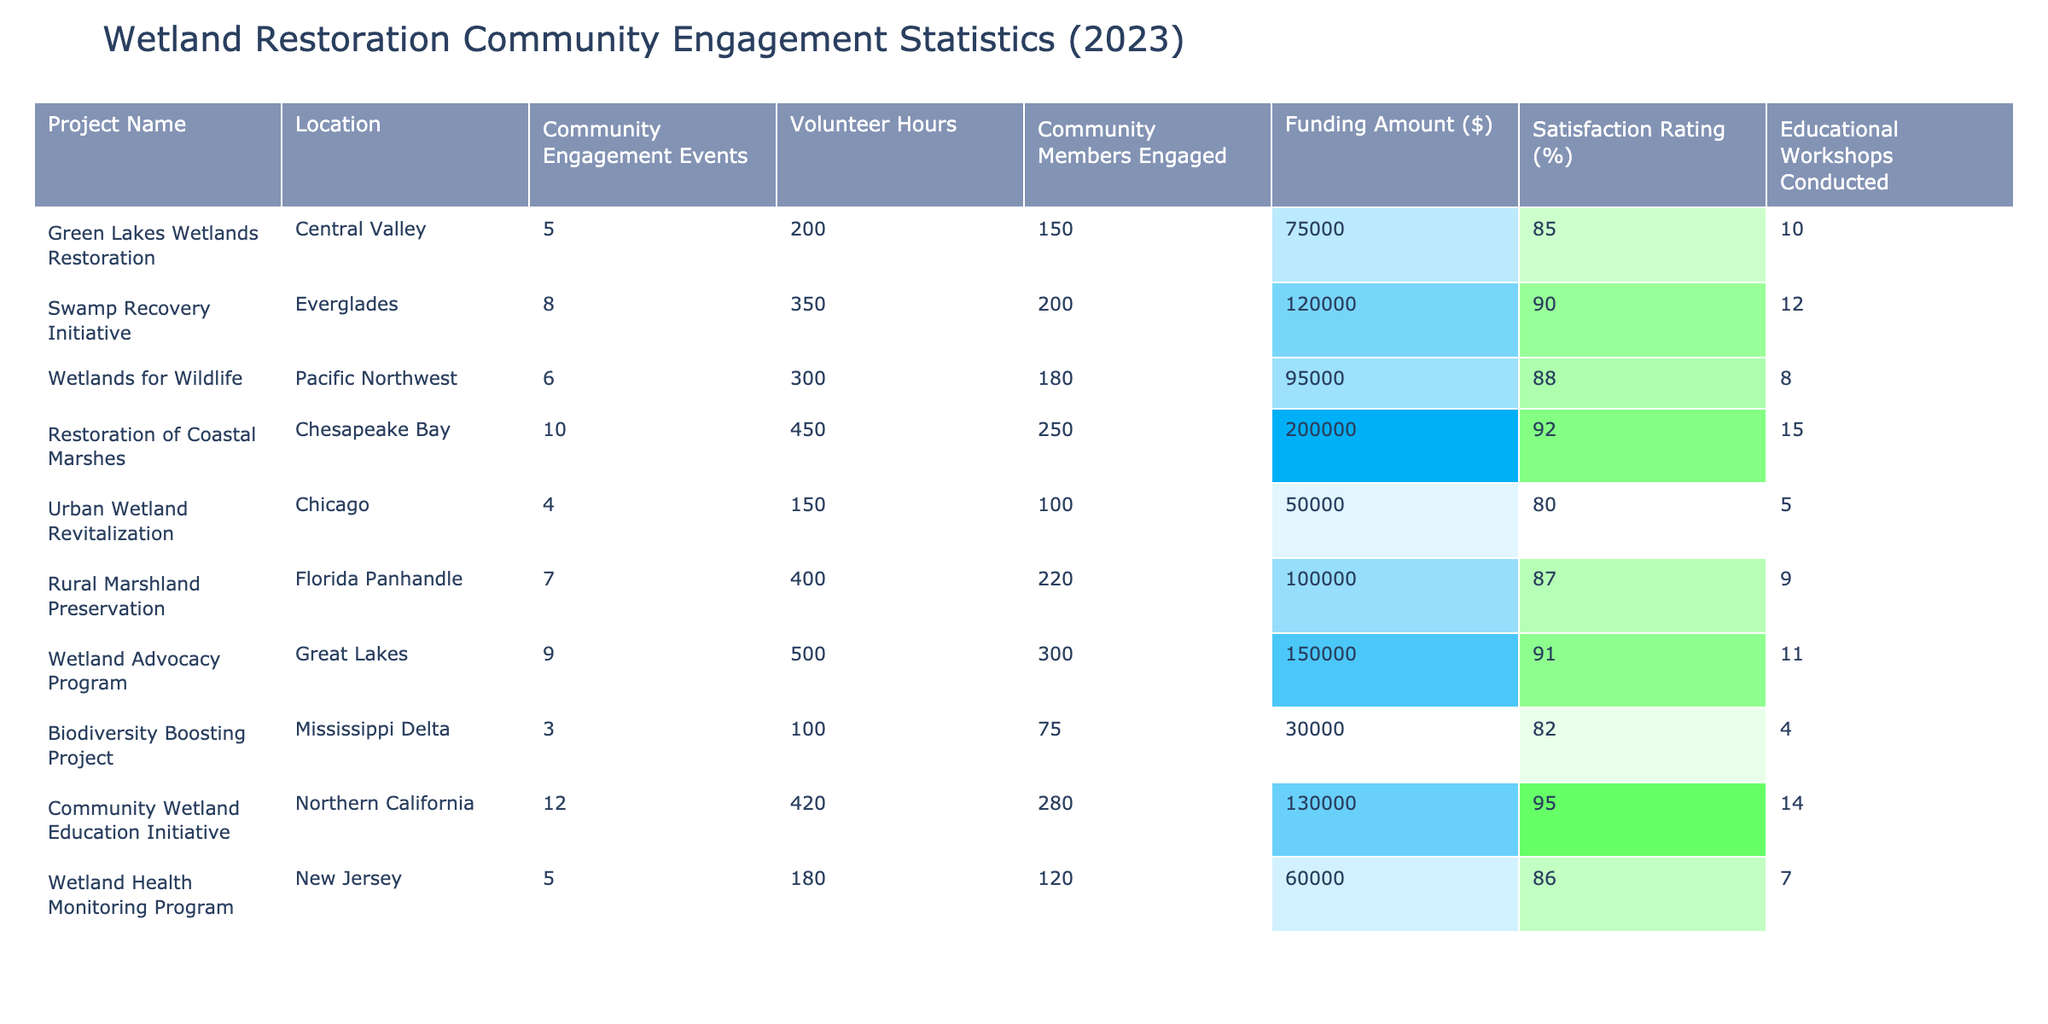What is the funding amount for the "Swamp Recovery Initiative"? The funding amount for the "Swamp Recovery Initiative" is listed in the table under the "Funding Amount ($)" column. The value given for this project is $120,000.
Answer: $120,000 How many community members were engaged in the "Urban Wetland Revitalization" project? The number of community members engaged in the "Urban Wetland Revitalization" project can be found in the "Community Members Engaged" column, which shows a value of 100.
Answer: 100 What is the satisfaction rating of the "Wetlands for Wildlife" project? The satisfaction rating is listed in the "Satisfaction Rating (%)" column. For the "Wetlands for Wildlife" project, the value is 88%.
Answer: 88% Which project had the highest number of community engagement events? To find the project with the highest number of community engagement events, we need to look at the "Community Engagement Events" column. The "Restoration of Coastal Marshes" project had 10 events, which is the highest.
Answer: Restoration of Coastal Marshes Calculate the average satisfaction rating for all projects. To calculate the average satisfaction rating, sum all the satisfaction ratings (85 + 90 + 88 + 92 + 80 + 87 + 91 + 82 + 95 + 86) =  891, and divide by the number of projects (10). So, the average is 891 / 10 = 89.1.
Answer: 89.1 Is the "Biodiversity Boosting Project" rated above 80% satisfaction? The satisfaction rating for the "Biodiversity Boosting Project" is 82%, which is above 80%. Therefore, the answer is yes.
Answer: Yes What is the total number of volunteer hours contributed to all projects combined? To find the total volunteer hours, we sum the volunteer hours from all projects: 200 + 350 + 300 + 450 + 150 + 400 + 500 + 100 + 420 + 180 = 3250.
Answer: 3250 Which project had the lowest satisfaction rating, and what was that rating? We need to compare the satisfaction ratings for each project and find the minimum. The lowest rating is 80% for the "Urban Wetland Revitalization" project.
Answer: Urban Wetland Revitalization, 80% How does the total funding amount relate to the number of community members engaged across projects? To find the relationship, we could analyze the funding amount per community member engaged. For instance, for the "Swamp Recovery Initiative", it is $120,000 for 200 members, which equates to $600 per member. Analyzing this across all projects would yield insights on funding efficiency.
Answer: Varies by project, requires detailed analysis Which project managed to engage the most community members with the least amount of funding? By looking at the "Community Members Engaged" and "Funding Amount ($)", we need to calculate the engagement per dollar spent. The "Biodiversity Boosting Project" engaged 75 members for $30,000, giving $400 per member, while others had a higher cost per member.
Answer: Biodiversity Boosting Project, most efficient engagement 